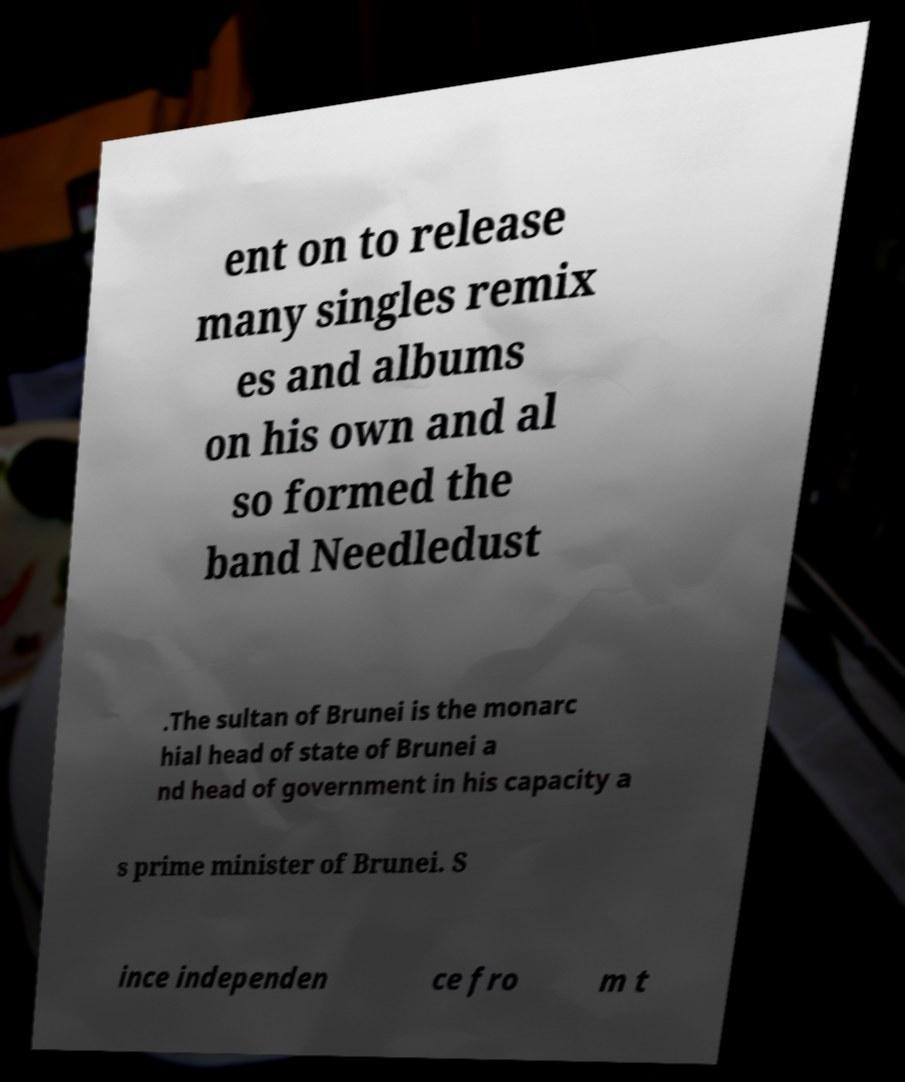I need the written content from this picture converted into text. Can you do that? ent on to release many singles remix es and albums on his own and al so formed the band Needledust .The sultan of Brunei is the monarc hial head of state of Brunei a nd head of government in his capacity a s prime minister of Brunei. S ince independen ce fro m t 